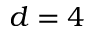<formula> <loc_0><loc_0><loc_500><loc_500>d = 4</formula> 